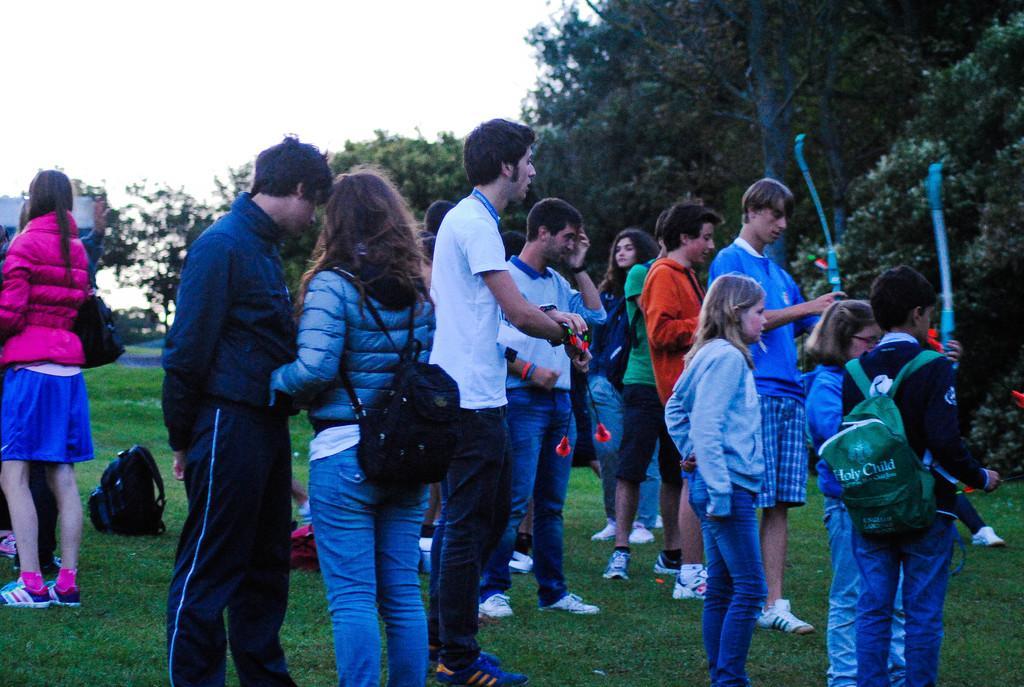Please provide a concise description of this image. In this image there are group of people standing on the ground. On the right side there are two kids who are holding the bow´s. In the middle there is a man who is holding the arrows. In the background there are so many trees. At the top there is the sky. On the ground there is grass. On the grass there is a bag. 